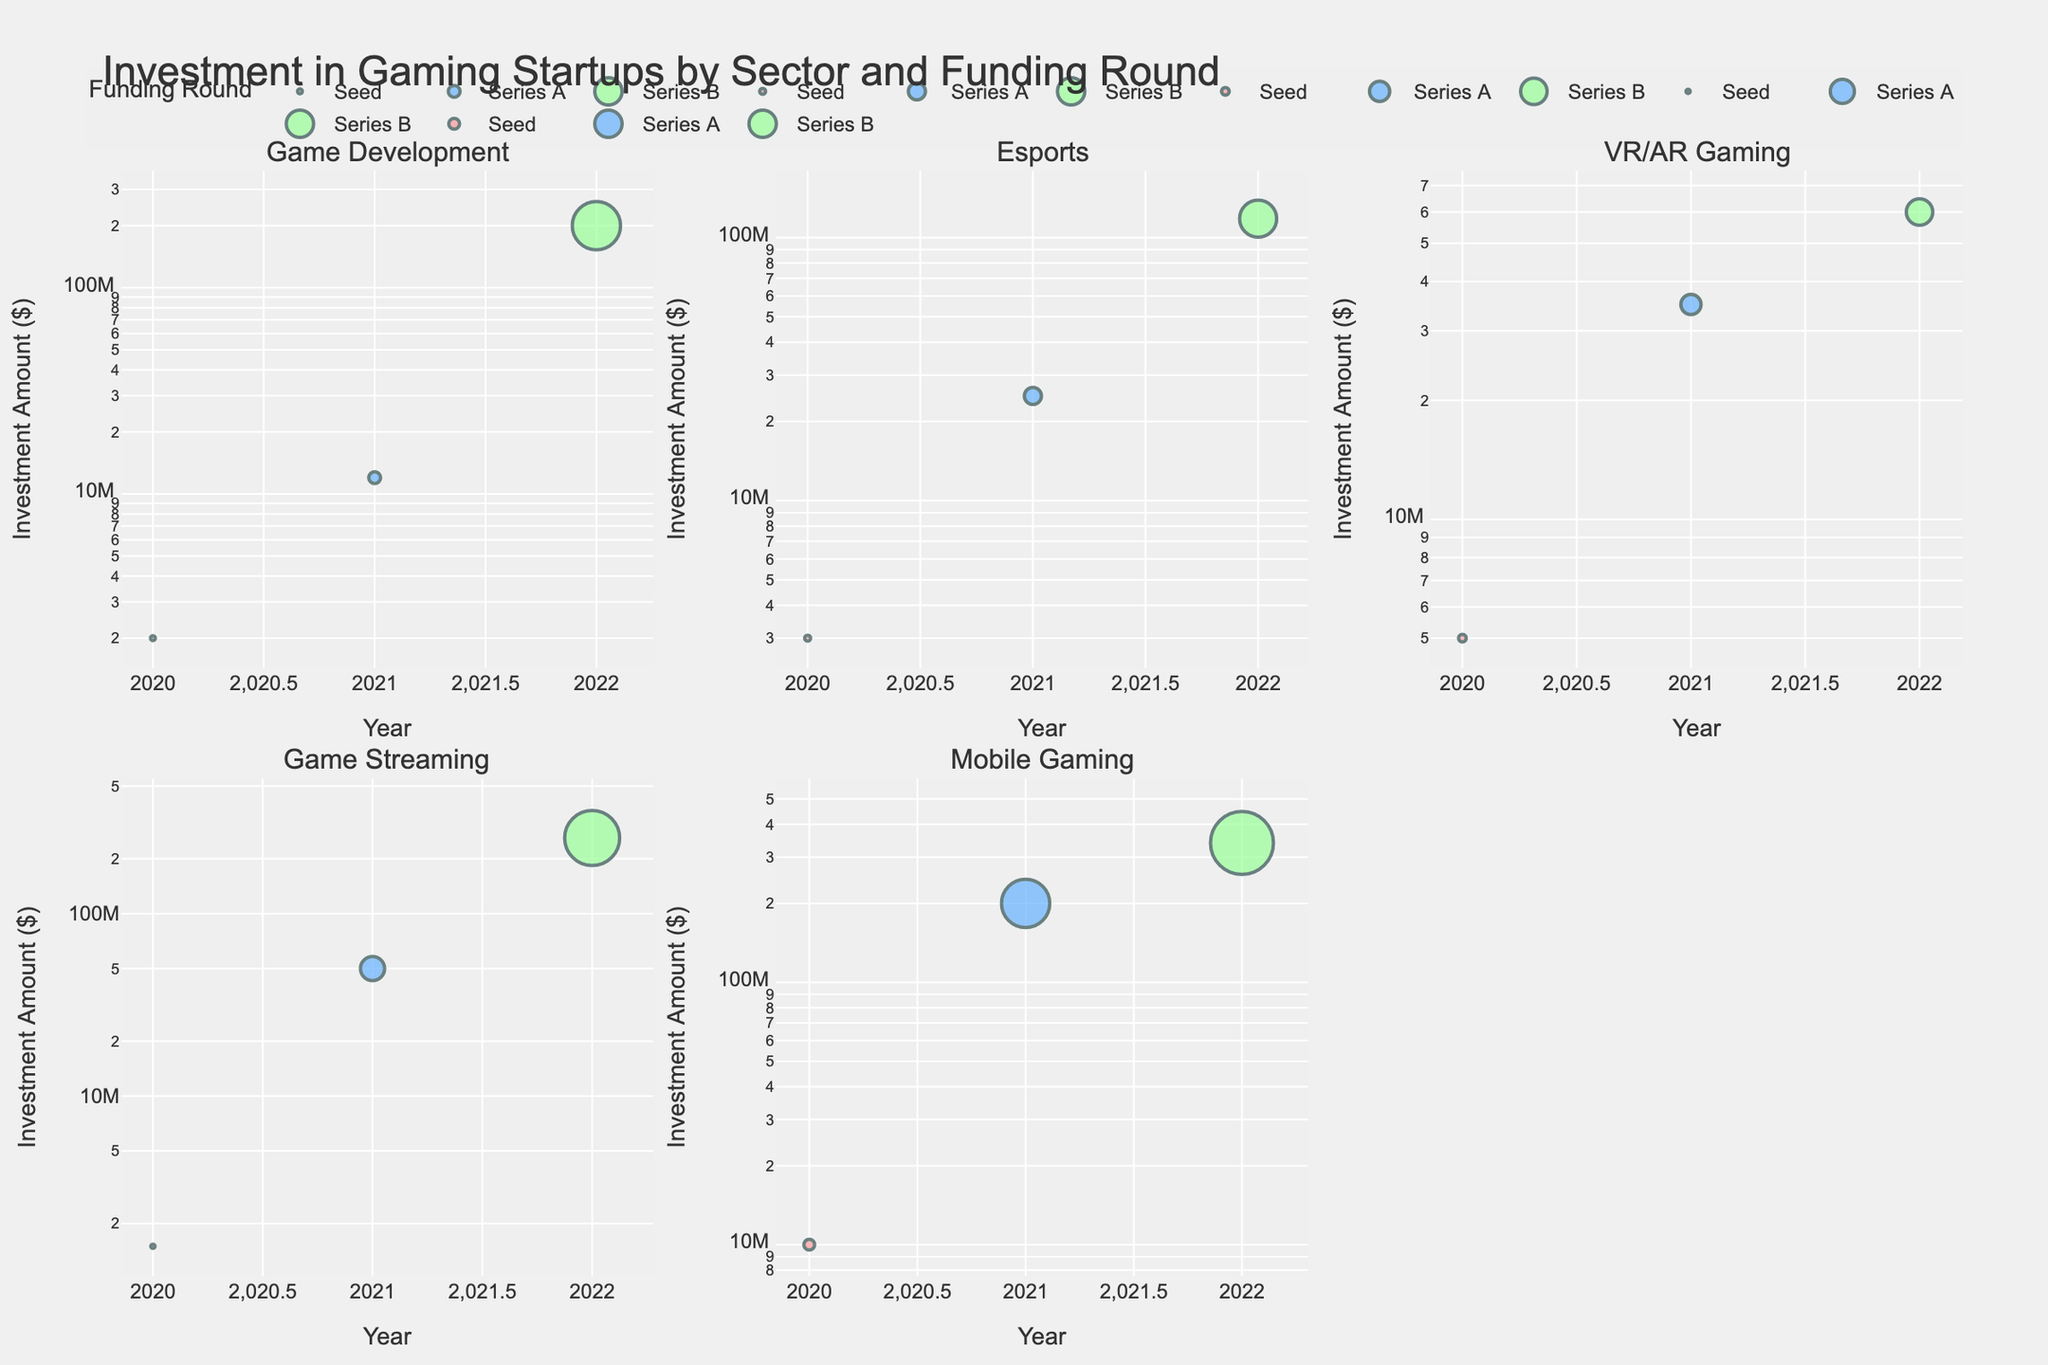What is the highest investment amount in the "Game Development" sector? The highest investment amount for the "Game Development" sector can be seen in the Series B round involving Niantic with an investment of $200,000,000.
Answer: $200,000,000 Which sector has the largest bubble for Series B funding round? In the subplot for each sector, the bubble size can be visually compared. The "Mobile Gaming" sector has the largest bubble for the Series B funding round, indicating the highest investment amount.
Answer: Mobile Gaming How does the investment amount change over the years in the "Esports" sector? To observe changes over the years, we look at the y-axis values for the Esports sector. In 2020, the investment was $3,000,000, in 2021, it was $25,000,000, and in 2022 it rose significantly to $118,000,000. This shows a substantial increase in investment over the years.
Answer: It increases significantly In which year did "Game Streaming" receive the highest investment? By examining the y-axis values within the "Game Streaming" subplot, it's evident that the highest investment occurred in 2022, which is $260,000,000 from Caffeine in the Series B round.
Answer: 2022 Compare the Series A funding round investment amounts between "VR/AR Gaming" and "Game Streaming" sectors. Which one is higher? Looking at the bubble sizes in the plots, "Game Streaming" has a Series A investment of $50,000,000 by Discord, whereas "VR/AR Gaming" has a Series A investment of $35,000,000 by nDreams. Therefore, the investment in "Game Streaming" is higher.
Answer: Game Streaming What trend do you observe in the "Mobile Gaming" sector from Seed to Series B funding rounds? The "Mobile Gaming" sector shows an increasing trend in the investment amount from Seed ($10,000,000) to Series A ($200,000,000) to Series B ($340,000,000), indicating growing interest and investment over successive funding rounds.
Answer: Increasing trend Which company received the Seed funding in the "VR/AR Gaming" sector, and what was the investment amount? By looking at the bubble for the Seed funding round in the "VR/AR Gaming" subplot, Owlchemy Labs received the Seed funding, and the investment amount was $5,000,000.
Answer: Owlchemy Labs, $5,000,000 What is the total investment amount in the "Game Development" sector across all years? Summing up the investment amounts in all funding rounds for the Game Development sector: $2,000,000 (Seed) + $12,000,000 (Series A) + $200,000,000 (Series B) = $214,000,000.
Answer: $214,000,000 How many bubbles are there in the "Esports" sector subplot? Each funding round in the Esports subplot has a bubble corresponding to the investment amount. There are three bubbles, one for each funding round: Seed, Series A, and Series B.
Answer: 3 